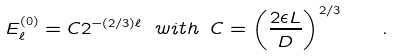<formula> <loc_0><loc_0><loc_500><loc_500>E _ { \ell } ^ { ( 0 ) } = C 2 ^ { - ( 2 / 3 ) \ell } \ w i t h \ C = \left ( \frac { 2 \epsilon L } { D } \right ) ^ { 2 / 3 } \quad .</formula> 